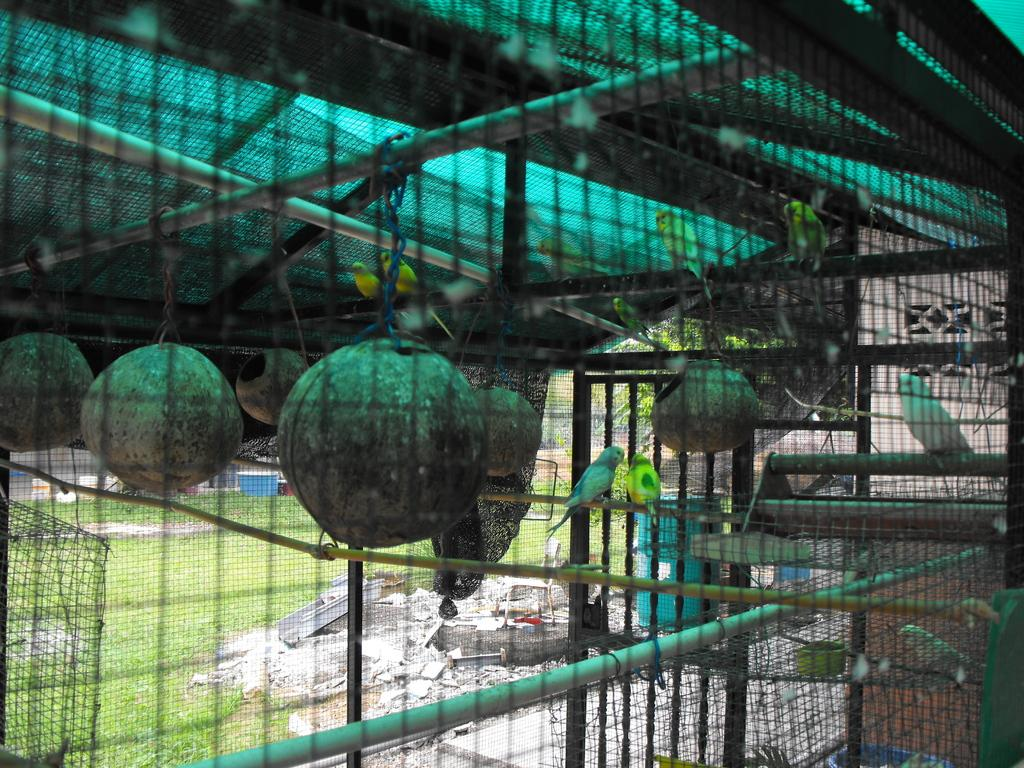What type of enclosure is present in the image? There is a cage with mesh in the image. What can be found inside the cage? There are pots and birds inside the cage. What is the ground surface like in the image? There is grass on the ground in the image. Can you find the receipt for the birds inside the cage? There is no receipt present in the image; it only shows a cage with pots and birds inside. 